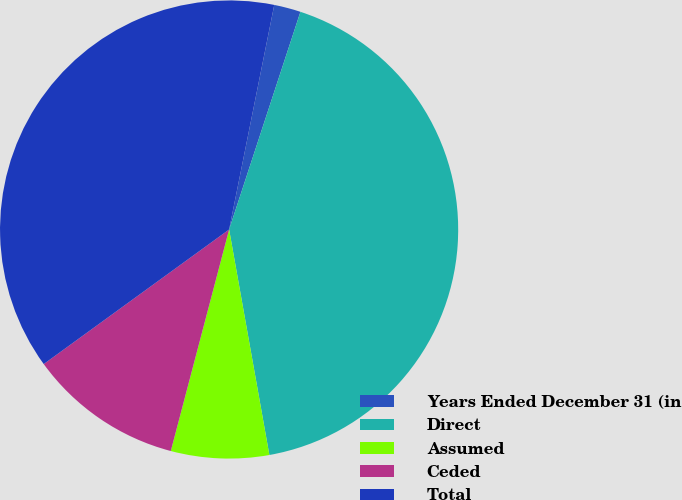Convert chart to OTSL. <chart><loc_0><loc_0><loc_500><loc_500><pie_chart><fcel>Years Ended December 31 (in<fcel>Direct<fcel>Assumed<fcel>Ceded<fcel>Total<nl><fcel>1.88%<fcel>42.15%<fcel>6.91%<fcel>10.91%<fcel>38.15%<nl></chart> 